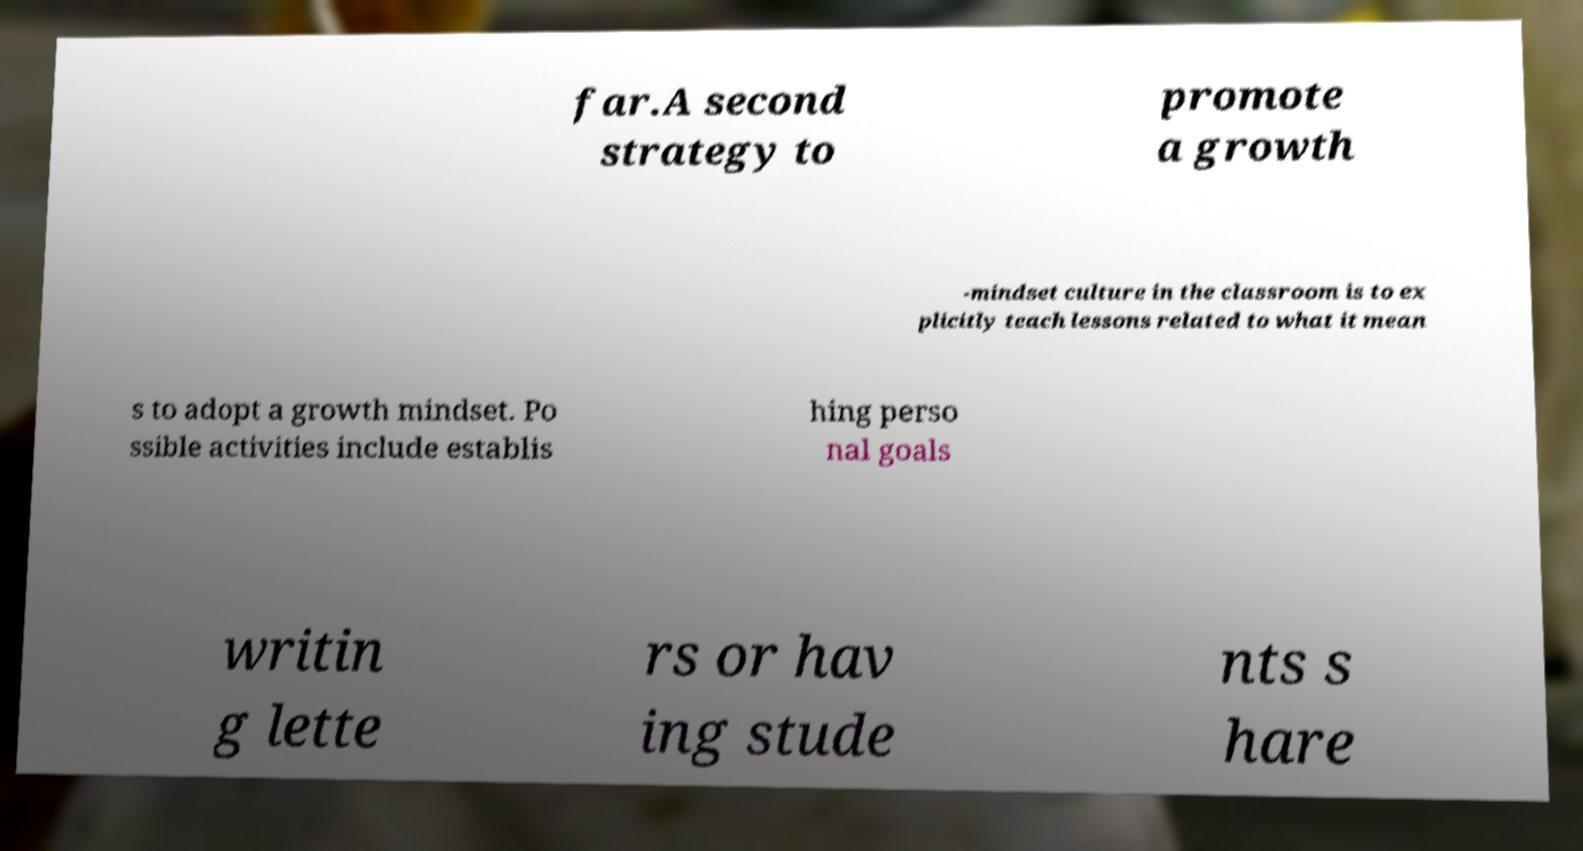For documentation purposes, I need the text within this image transcribed. Could you provide that? far.A second strategy to promote a growth -mindset culture in the classroom is to ex plicitly teach lessons related to what it mean s to adopt a growth mindset. Po ssible activities include establis hing perso nal goals writin g lette rs or hav ing stude nts s hare 